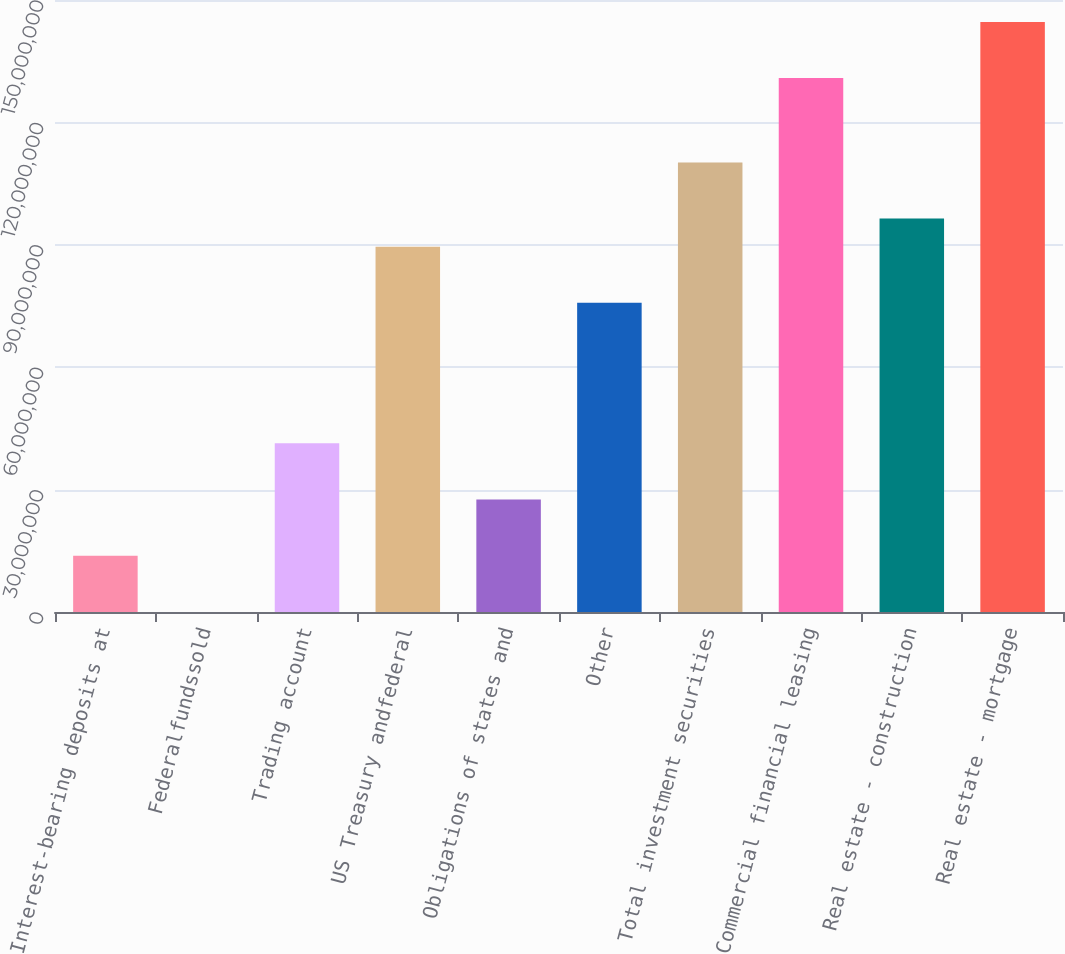Convert chart. <chart><loc_0><loc_0><loc_500><loc_500><bar_chart><fcel>Interest-bearing deposits at<fcel>Federalfundssold<fcel>Trading account<fcel>US Treasury andfederal<fcel>Obligations of states and<fcel>Other<fcel>Total investment securities<fcel>Commercial financial leasing<fcel>Real estate - construction<fcel>Real estate - mortgage<nl><fcel>1.37922e+07<fcel>20119<fcel>4.13363e+07<fcel>8.95385e+07<fcel>2.75642e+07<fcel>7.57664e+07<fcel>1.10197e+08<fcel>1.30855e+08<fcel>9.64245e+07<fcel>1.44627e+08<nl></chart> 